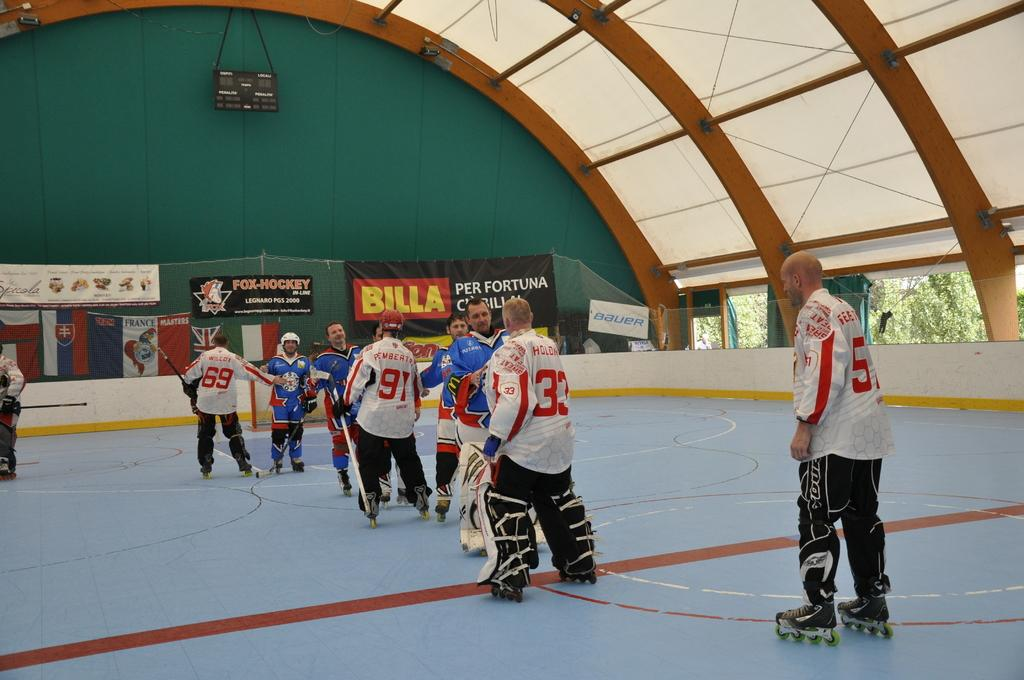<image>
Render a clear and concise summary of the photo. A sign says "BILLA" above a hockey rink. 